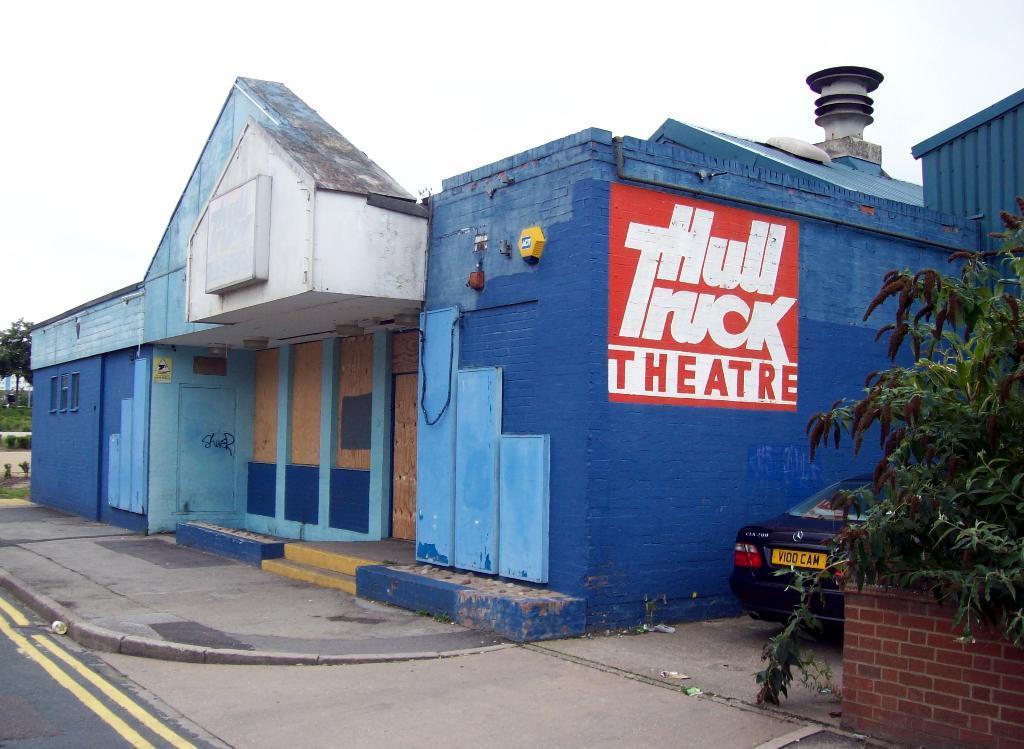Can you describe this image briefly? In this image I can see the building. To the right I can see the plant, brick wall and the vehicle. In the background I can see the trees and the sky. 